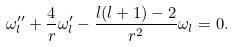<formula> <loc_0><loc_0><loc_500><loc_500>\omega _ { l } ^ { \prime \prime } + \frac { 4 } { r } \omega _ { l } ^ { \prime } - \frac { l ( l + 1 ) - 2 } { r ^ { 2 } } \omega _ { l } = 0 .</formula> 